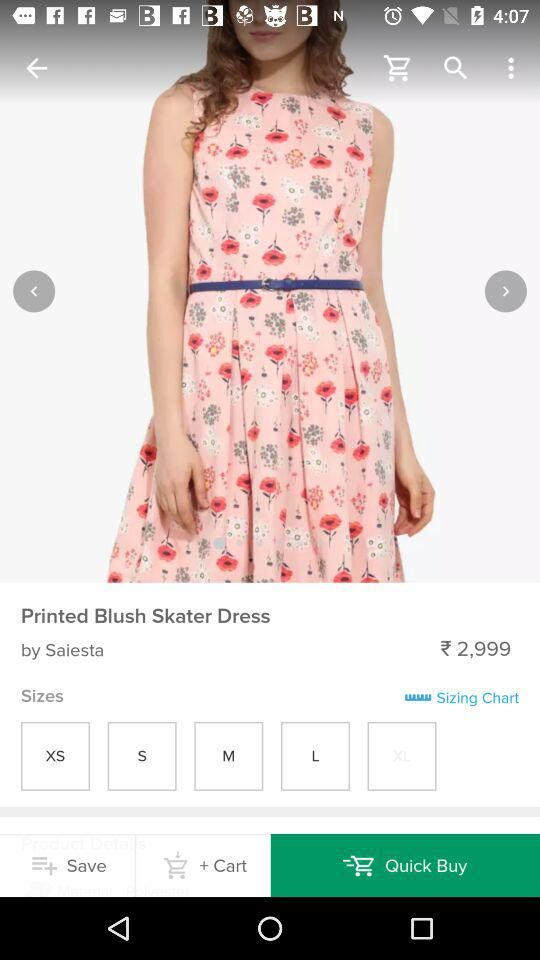What is the brand of this dress? The brand of this dress is "Saiesta". 